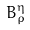<formula> <loc_0><loc_0><loc_500><loc_500>B _ { \rho } ^ { \eta }</formula> 